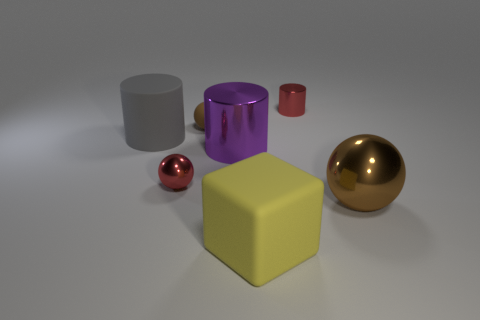What number of objects are spheres that are on the right side of the big rubber cube or balls that are left of the small red metal cylinder?
Offer a terse response. 3. What color is the matte ball?
Your answer should be compact. Brown. How many large gray cylinders are the same material as the small brown object?
Your answer should be very brief. 1. Is the number of gray matte cylinders greater than the number of red matte objects?
Give a very brief answer. Yes. How many balls are to the right of the small red metallic cylinder that is right of the yellow thing?
Provide a short and direct response. 1. What number of objects are big things that are in front of the big brown object or matte things?
Your answer should be compact. 3. Are there any other tiny things that have the same shape as the purple shiny thing?
Provide a short and direct response. Yes. What is the shape of the small red metal thing to the left of the tiny red metallic thing to the right of the yellow object?
Your answer should be compact. Sphere. How many spheres are large gray objects or brown objects?
Your answer should be compact. 2. There is another ball that is the same color as the big sphere; what is it made of?
Provide a short and direct response. Rubber. 